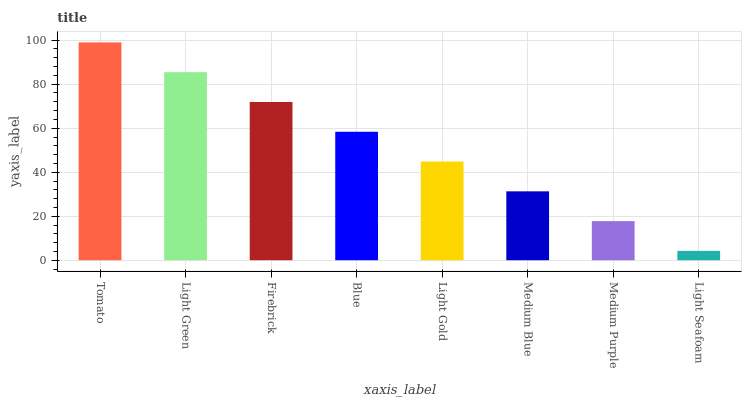Is Light Seafoam the minimum?
Answer yes or no. Yes. Is Tomato the maximum?
Answer yes or no. Yes. Is Light Green the minimum?
Answer yes or no. No. Is Light Green the maximum?
Answer yes or no. No. Is Tomato greater than Light Green?
Answer yes or no. Yes. Is Light Green less than Tomato?
Answer yes or no. Yes. Is Light Green greater than Tomato?
Answer yes or no. No. Is Tomato less than Light Green?
Answer yes or no. No. Is Blue the high median?
Answer yes or no. Yes. Is Light Gold the low median?
Answer yes or no. Yes. Is Medium Purple the high median?
Answer yes or no. No. Is Tomato the low median?
Answer yes or no. No. 